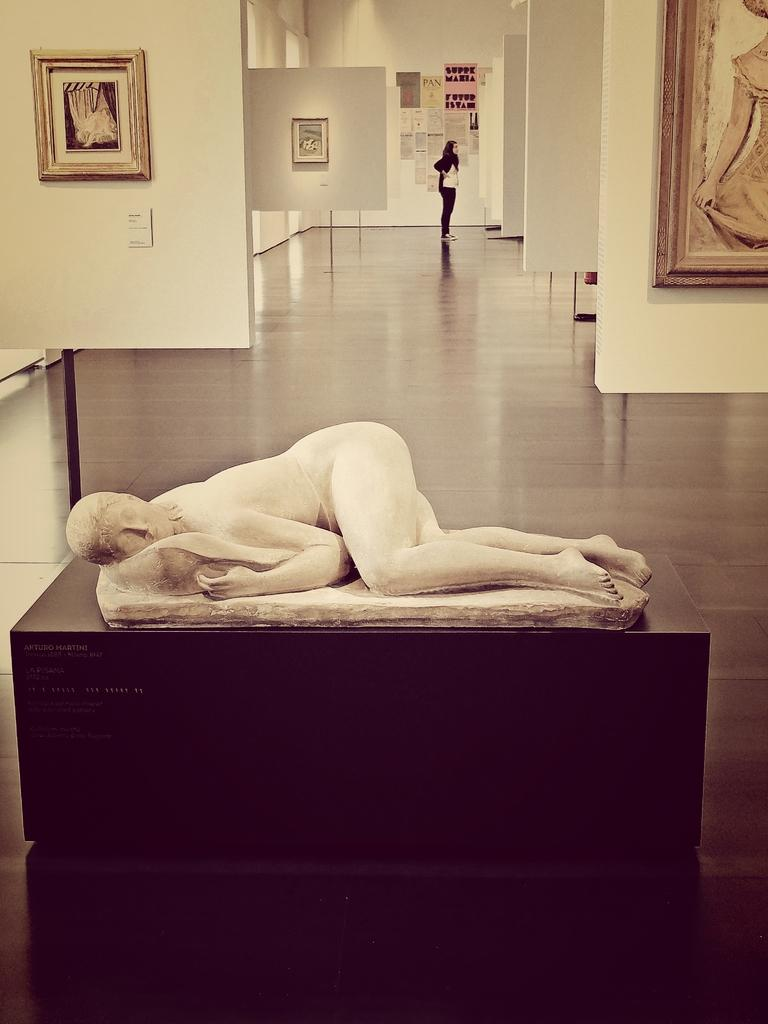What is the main subject in the image? There is a statue in the image. How is the statue positioned in the image? The statue is laying on some object. Can you describe the background of the image? There is a person standing in the background of the image. What can be seen attached to the wall in the image? There are frames attached to the wall. What color is the wall in the image? The wall is white in color. Can you see any drains in the image? There are no drains visible in the image. What type of crack is present on the statue in the image? There is no crack present on the statue in the image. 